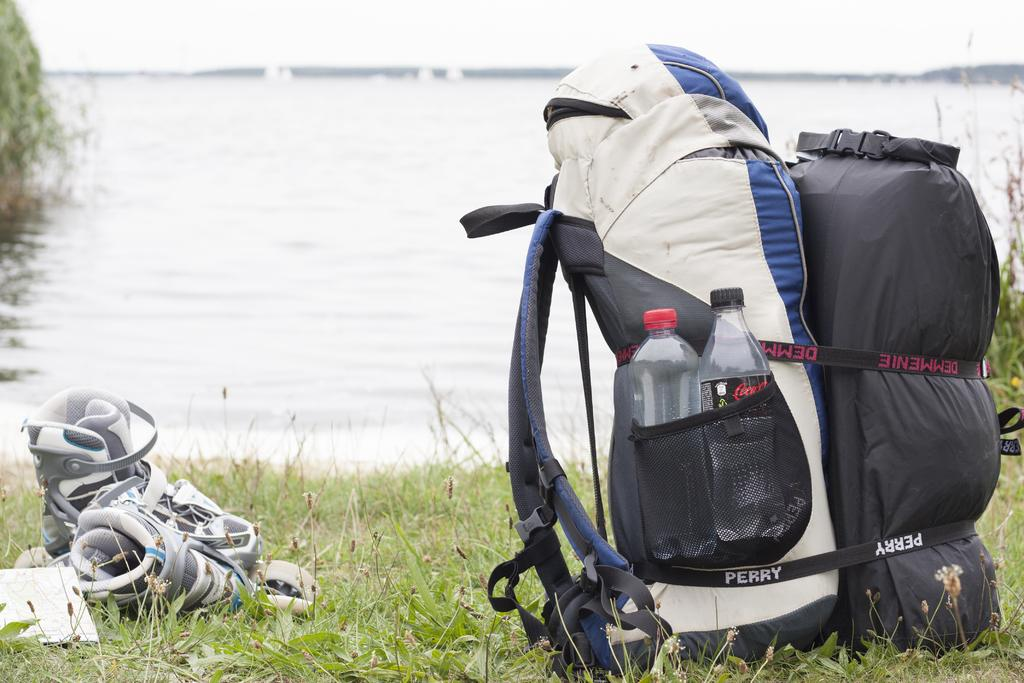<image>
Present a compact description of the photo's key features. Next to a lake sits a pair of athletic shoes and some camping gear held together with straps marked 'Perry' and 'Demmenie'. 